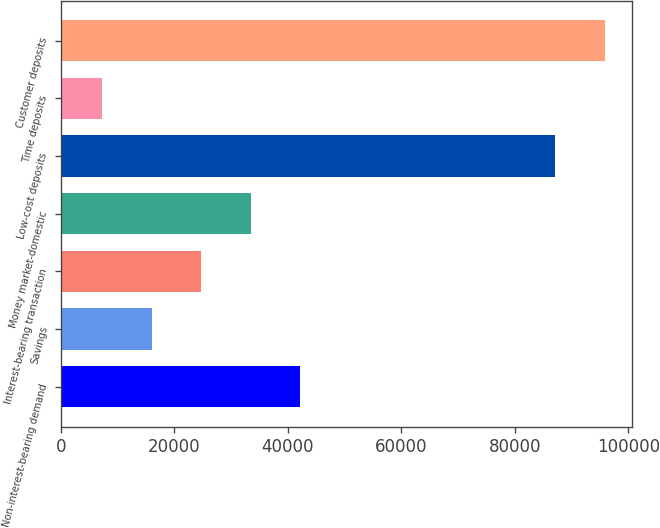<chart> <loc_0><loc_0><loc_500><loc_500><bar_chart><fcel>Non-interest-bearing demand<fcel>Savings<fcel>Interest-bearing transaction<fcel>Money market-domestic<fcel>Low-cost deposits<fcel>Time deposits<fcel>Customer deposits<nl><fcel>42214.8<fcel>16076.7<fcel>24789.4<fcel>33502.1<fcel>87127<fcel>7364<fcel>95839.7<nl></chart> 